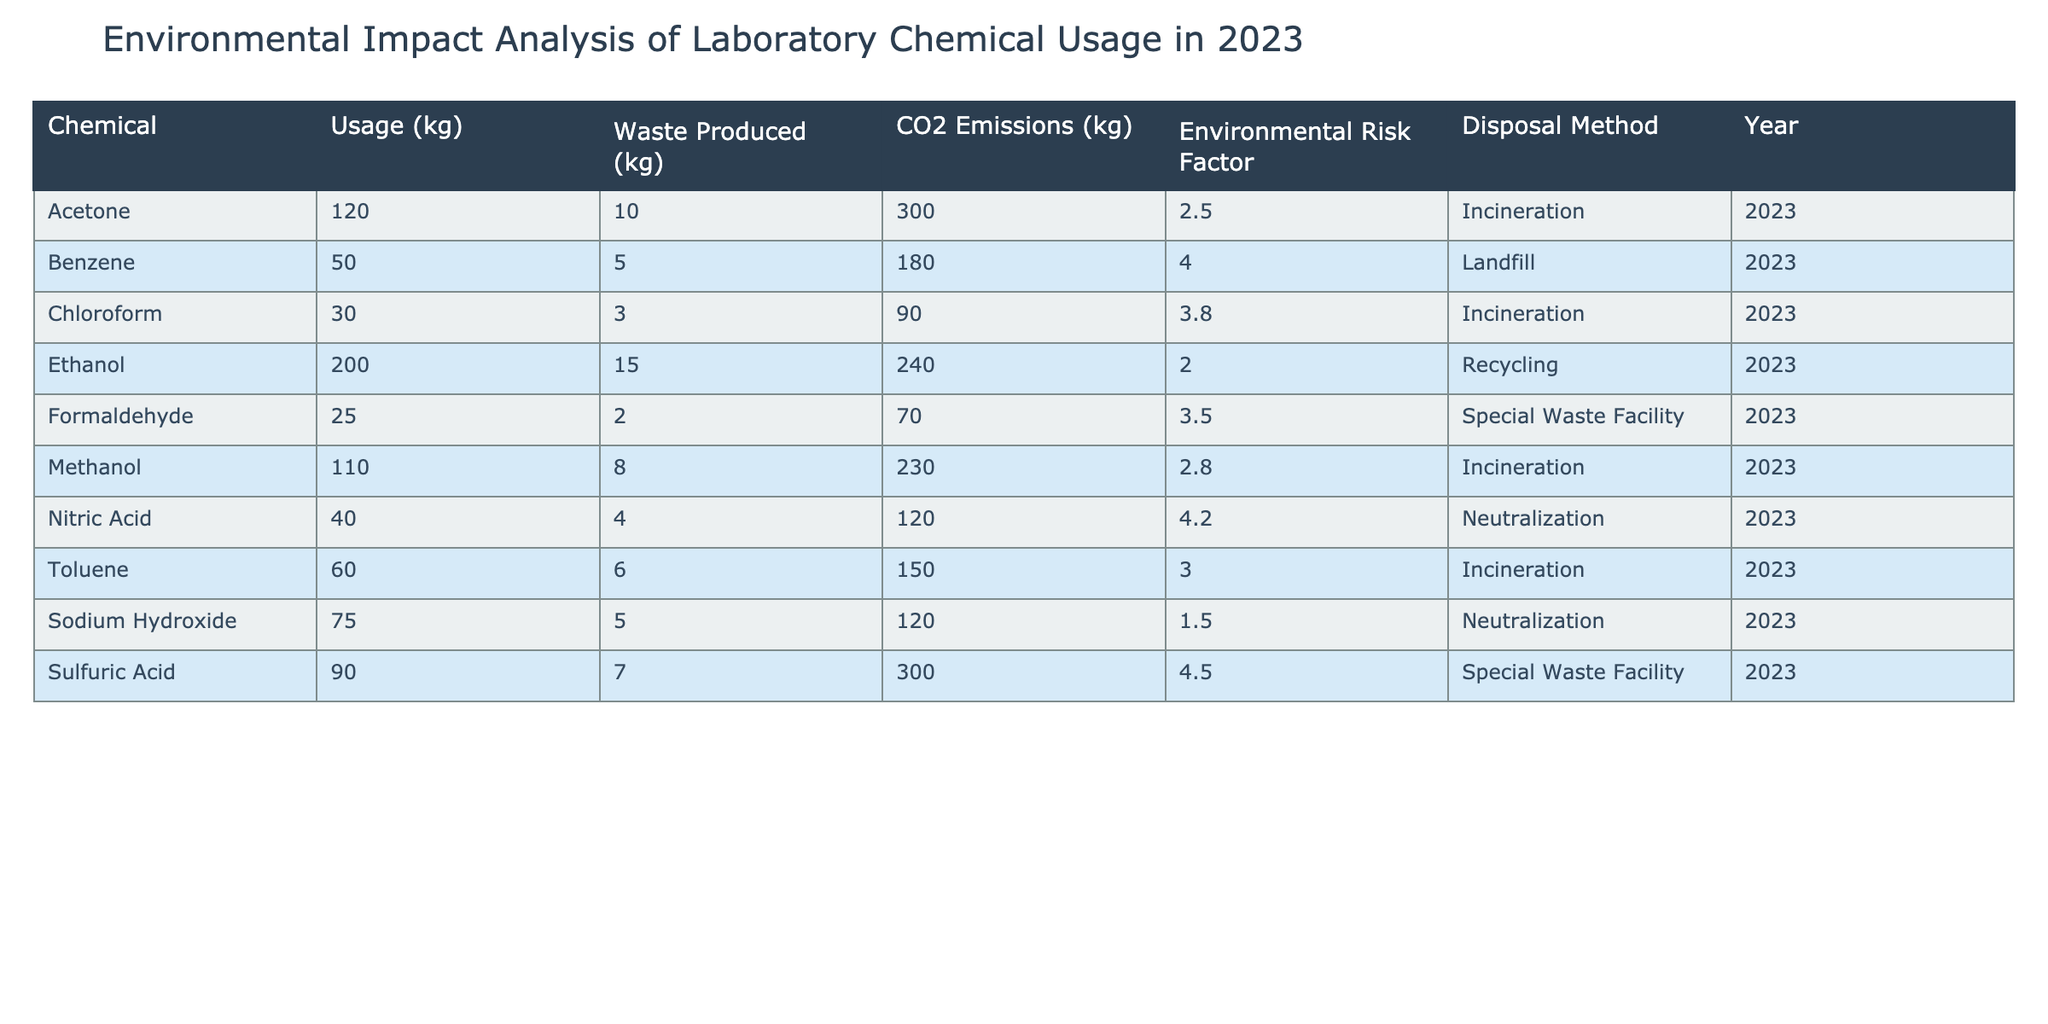What is the total CO2 emissions produced by all chemicals listed? To find the total CO2 emissions, we need to sum up the CO2 emission values for each chemical. The individual emissions are: 300 + 180 + 90 + 240 + 70 + 230 + 120 + 150 + 120 + 300 = 1,800 kg.
Answer: 1800 kg Which chemical has the highest environmental risk factor? By examining the Environmental Risk Factor column, the highest value is 4.5 associated with Sulfuric Acid.
Answer: Sulfuric Acid Is Ethanol disposed of using incineration? The Disposal Method for Ethanol is Recycling, not Incineration. Therefore, the statement is false.
Answer: No What is the average usage of chemicals in kilograms? To find the average usage, sum the Usage values: 120 + 50 + 30 + 200 + 25 + 110 + 40 + 60 + 75 + 90 = 800 kg. Then divide it by the number of chemicals (10): 800 / 10 = 80 kg.
Answer: 80 kg Do any chemicals produce more than 10 kg of waste? Reviewing the Waste Produced column, several chemicals exceed 10 kg: Acetone (10 kg), Ethanol (15 kg), and Methanol (8 kg) do not count since only the first two exceed 10 kg. Therefore, yes, there are chemicals that produce more than 10 kg of waste.
Answer: Yes Which disposal method is used for Nitric Acid? Referring to the Disposal Method column, Nitric Acid is disposed of using Neutralization.
Answer: Neutralization What is the difference in CO2 emissions between the chemical with the highest and lowest emissions? The highest CO2 emissions are from Acetone (300 kg) and the lowest emissions are from Chloroform (90 kg). The difference is calculated as: 300 - 90 = 210 kg.
Answer: 210 kg Which chemical produces the least waste? By comparing the Waste Produced column, Formaldehyde produces the least waste at 2 kg.
Answer: Formaldehyde How many chemicals are disposed of using a special waste facility? In the Disposal Method column, there are two chemicals listed with Special Waste Facility: Formaldehyde and Sulfuric Acid. Therefore, there are two chemicals.
Answer: 2 